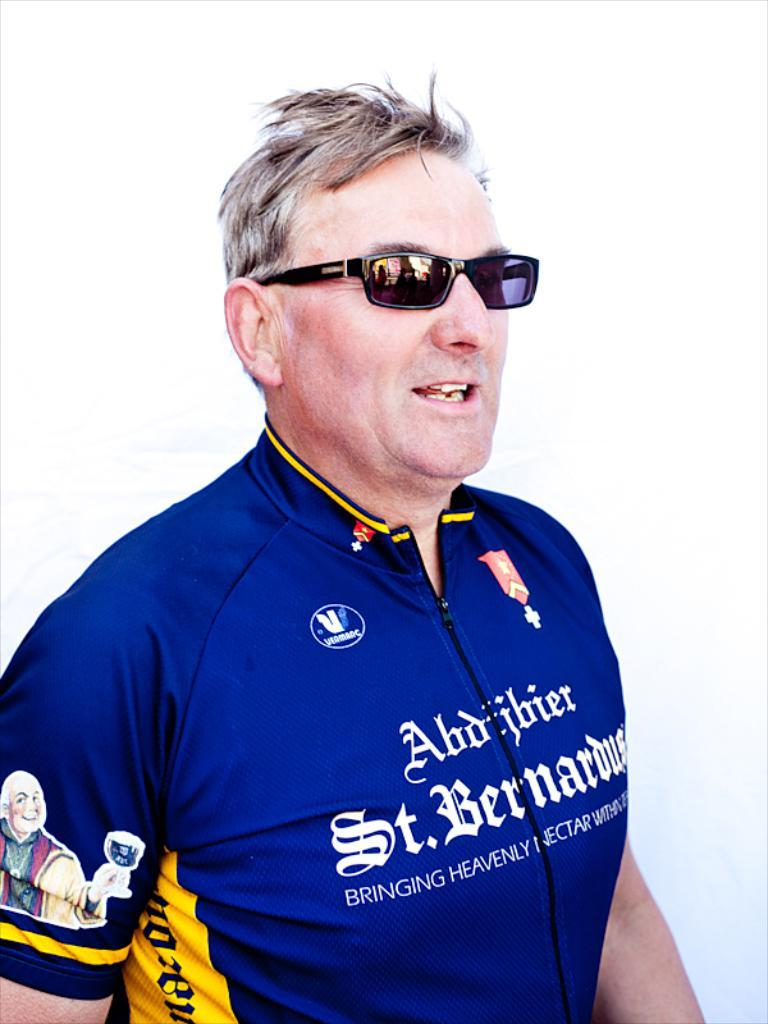<image>
Share a concise interpretation of the image provided. a person wearing a blue jersey that has the word St. on it 